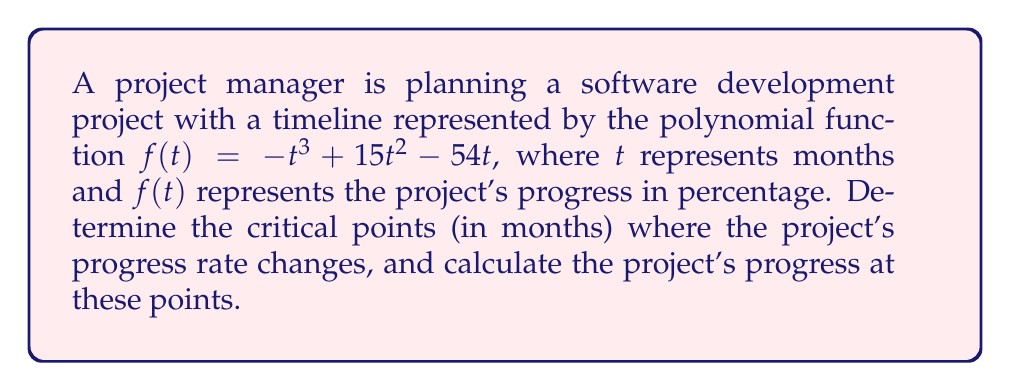Help me with this question. To solve this problem, we'll follow these steps:

1) First, we need to find the derivative of $f(t)$ to represent the rate of progress:
   $f'(t) = -3t^2 + 30t - 54$

2) The critical points occur where $f'(t) = 0$. So, we need to solve:
   $-3t^2 + 30t - 54 = 0$

3) This is a quadratic equation. We can solve it using the quadratic formula:
   $t = \frac{-b \pm \sqrt{b^2 - 4ac}}{2a}$

   Where $a = -3$, $b = 30$, and $c = -54$

4) Substituting these values:
   $t = \frac{-30 \pm \sqrt{30^2 - 4(-3)(-54)}}{2(-3)}$
   $= \frac{-30 \pm \sqrt{900 - 648}}{-6}$
   $= \frac{-30 \pm \sqrt{252}}{-6}$
   $= \frac{-30 \pm 6\sqrt{7}}{-6}$

5) Simplifying:
   $t = 5 \pm \sqrt{7}$

6) Therefore, the critical points are:
   $t_1 = 5 - \sqrt{7} \approx 2.35$ months
   $t_2 = 5 + \sqrt{7} \approx 7.65$ months

7) To find the project's progress at these points, we substitute these values back into the original function:

   For $t_1$:
   $f(5-\sqrt{7}) = -(5-\sqrt{7})^3 + 15(5-\sqrt{7})^2 - 54(5-\sqrt{7})$
   $\approx 29.63\%$

   For $t_2$:
   $f(5+\sqrt{7}) = -(5+\sqrt{7})^3 + 15(5+\sqrt{7})^2 - 54(5+\sqrt{7})$
   $\approx 70.37\%$
Answer: Critical points: $5 - \sqrt{7}$ and $5 + \sqrt{7}$ months. Progress: 29.63% and 70.37% respectively. 